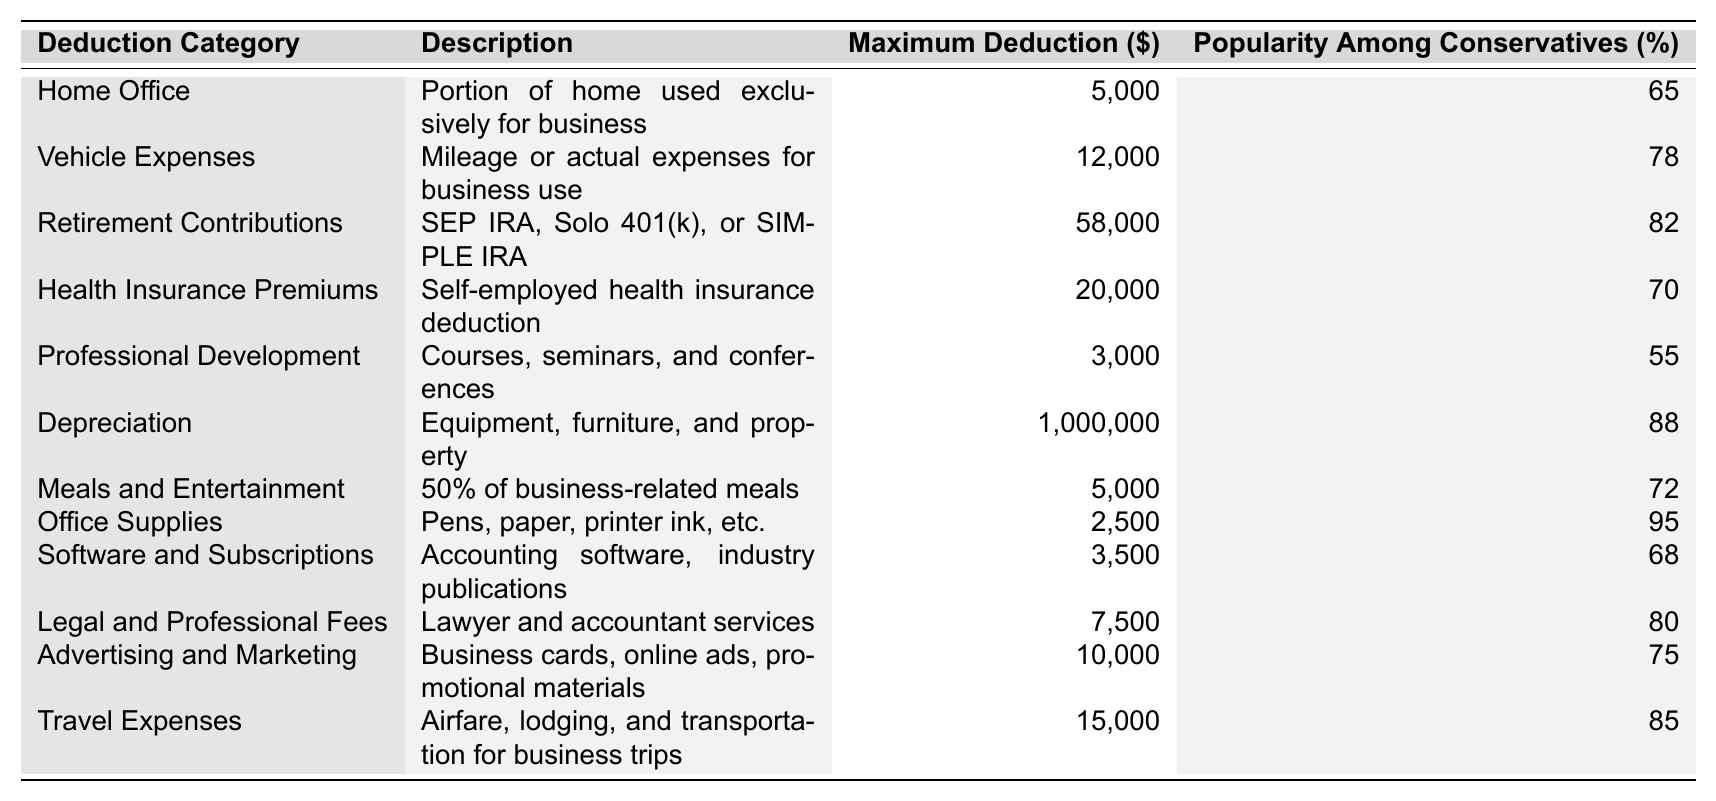What is the maximum deduction for vehicle expenses? The table shows that the maximum deduction for vehicle expenses is listed in the "Maximum Deduction" column corresponding to the "Vehicle Expenses" row, which is $12,000.
Answer: 12,000 Which deduction category has the highest popularity among conservatives? The "Popularity Among Conservatives" column indicates that "Depreciation" has the highest percentage at 88%, making it the most popular category.
Answer: Depreciation What is the total maximum deduction for meals and entertainment combined with office supplies? To find the total, we add the maximum deductions for "Meals and Entertainment" ($5,000) and "Office Supplies" ($2,500): 5,000 + 2,500 = 7,500.
Answer: 7,500 Is the maximum deduction for health insurance premiums greater than that for professional development? Looking at the respective maximum deductions, "Health Insurance Premiums" has a maximum of $20,000 and "Professional Development" has $3,000. Since $20,000 is greater than $3,000, the answer is yes.
Answer: Yes How much more can a business owner deduct for retirement contributions compared to office supplies? The maximum deduction for retirement contributions is $58,000, and for office supplies, it is $2,500. Subtracting these gives us: 58,000 - 2,500 = 55,500.
Answer: 55,500 What percentage of conservatives prefer office supplies as a deduction? The table shows that the popularity among conservatives for office supplies is 95%, directly stated in the "Popularity Among Conservatives" column.
Answer: 95% If a business owner claimed the maximum deduction for both travel expenses and vehicle expenses, how much would that total? The maximum deduction for "Travel Expenses" is $15,000 and for "Vehicle Expenses" is $12,000. Adding these gives: 15,000 + 12,000 = 27,000.
Answer: 27,000 Is the maximum deduction for depreciation more than 10 times that of professional development? The maximum deduction for depreciation is $1,000,000 and for professional development is $3,000. Ten times the professional development deduction is 10 x 3,000 = 30,000. Since $1,000,000 is greater than $30,000, the answer is yes.
Answer: Yes What is the average popularity percentage among conservatives for the deductions listed? First, we add all the popularity percentages: 65 + 78 + 82 + 70 + 55 + 88 + 72 + 95 + 68 + 80 + 75 + 85 =  100. To find the average, we divide this sum ( 1000) by the number of categories (12): 1000 / 12 = 83.33.
Answer: 83.33 What is the total maximum deduction for all of the listed categories? We sum the maximum deductions for all categories: 5,000 + 12,000 + 58,000 + 20,000 + 3,000 + 1,000,000 + 5,000 + 2,500 + 3,500 + 7,500 + 10,000 + 15,000 = 1,115,000.
Answer: 1,115,000 